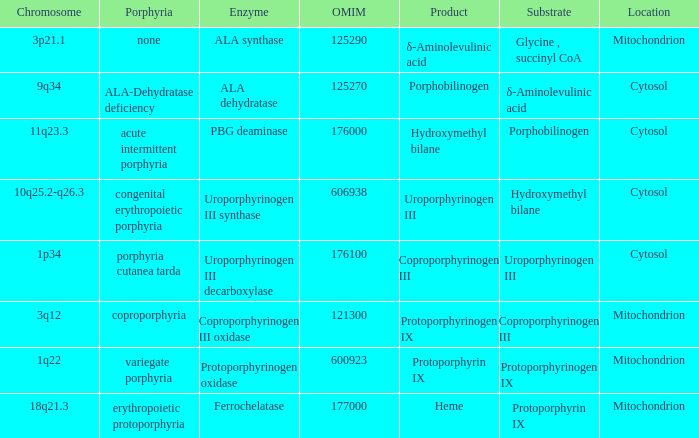What is the location of the enzyme Uroporphyrinogen iii Synthase? Cytosol. 